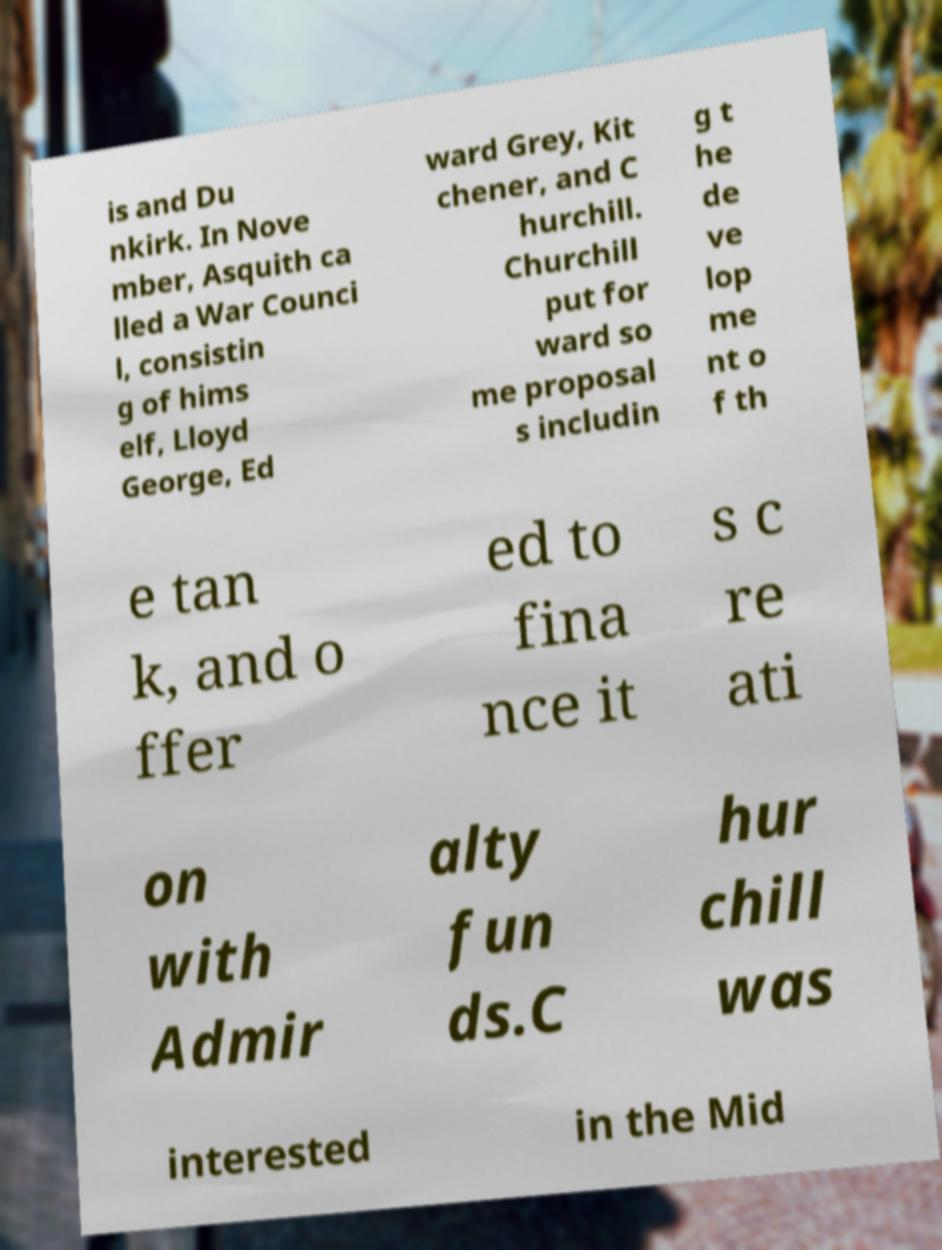Please read and relay the text visible in this image. What does it say? is and Du nkirk. In Nove mber, Asquith ca lled a War Counci l, consistin g of hims elf, Lloyd George, Ed ward Grey, Kit chener, and C hurchill. Churchill put for ward so me proposal s includin g t he de ve lop me nt o f th e tan k, and o ffer ed to fina nce it s c re ati on with Admir alty fun ds.C hur chill was interested in the Mid 